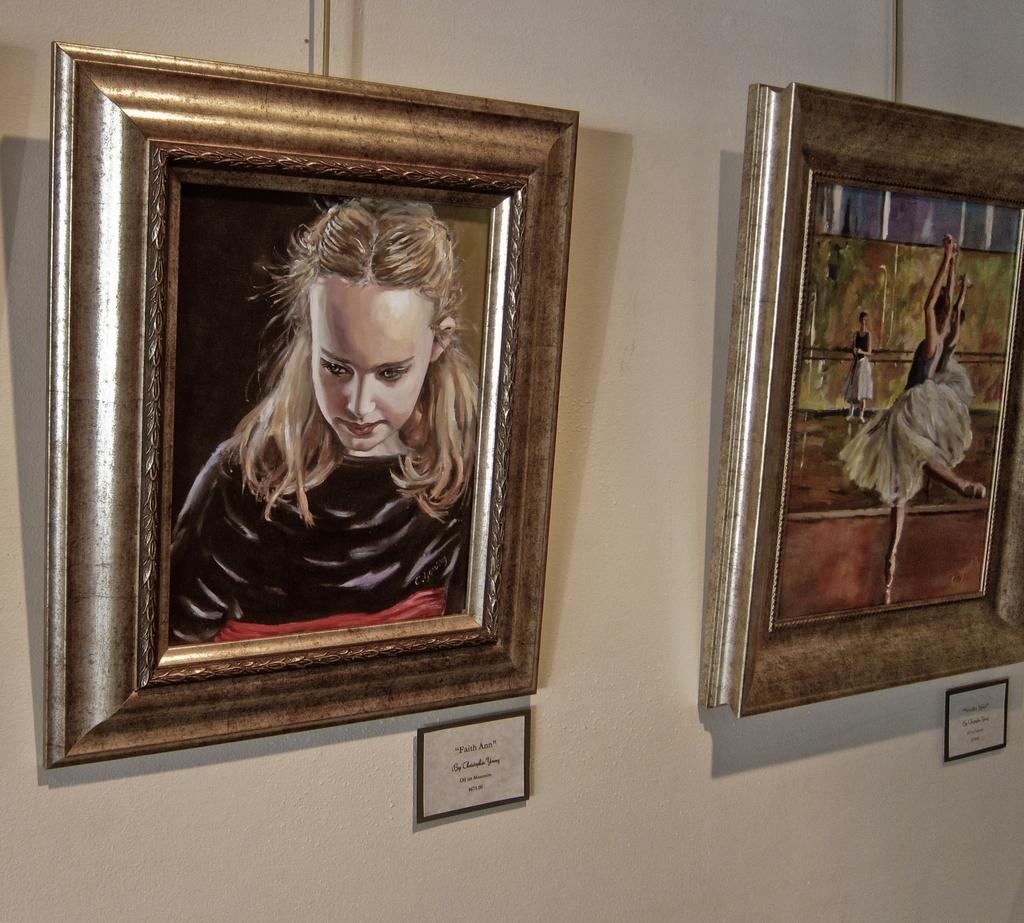How many picture frames are in the image? There are two picture frames in the image. What is inside the picture frames? The picture frames contain paintings. What is located under the picture frames? There are boards with text under the frames. How are the boards with text positioned in the image? The boards are attached to the wall. Are there any fictional characters depicted in the paintings within the picture frames? There is no information about the content of the paintings within the picture frames, so it cannot be determined if there are any fictional characters depicted. Can you see any icicles hanging from the picture frames in the image? There are no icicles present in the image; the focus is on the picture frames, paintings, and boards with text. 